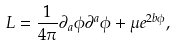<formula> <loc_0><loc_0><loc_500><loc_500>L = \frac { 1 } { 4 \pi } \partial _ { a } \phi \partial ^ { a } \phi + \mu e ^ { 2 b \phi } ,</formula> 